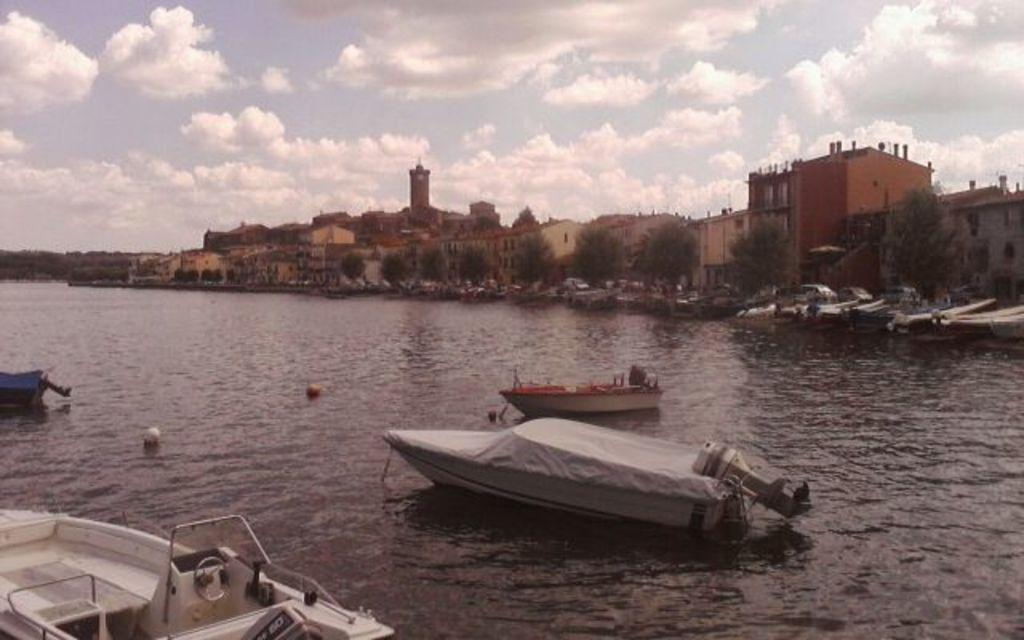What is the main feature of the landscape in the picture? There is a river in the picture. What is present in the river? There are boats in the river. What can be seen in the background of the picture? There are trees and buildings in the backdrop of the picture. How would you describe the sky in the image? The sky is clear in the image. How many bones can be seen in the river in the image? There are no bones present in the image; it features a river with boats. What is the amount of afterthought given to the design of the trees in the image? The provided facts do not mention anything about the design or afterthought given to the trees, so it cannot be determined from the image. 